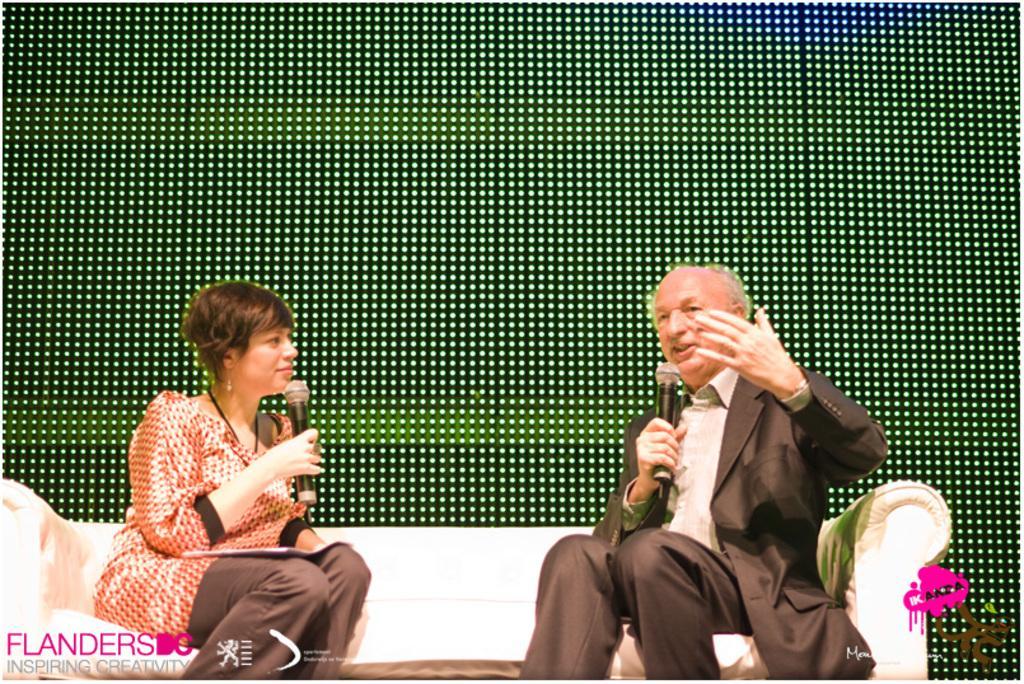Could you give a brief overview of what you see in this image? This picture might be taken inside a room. In this image, we can see a couch, on that couch, we can see two people man and woman are sitting and they are also holding microphones in their hands. In the background, we can see some lights. 